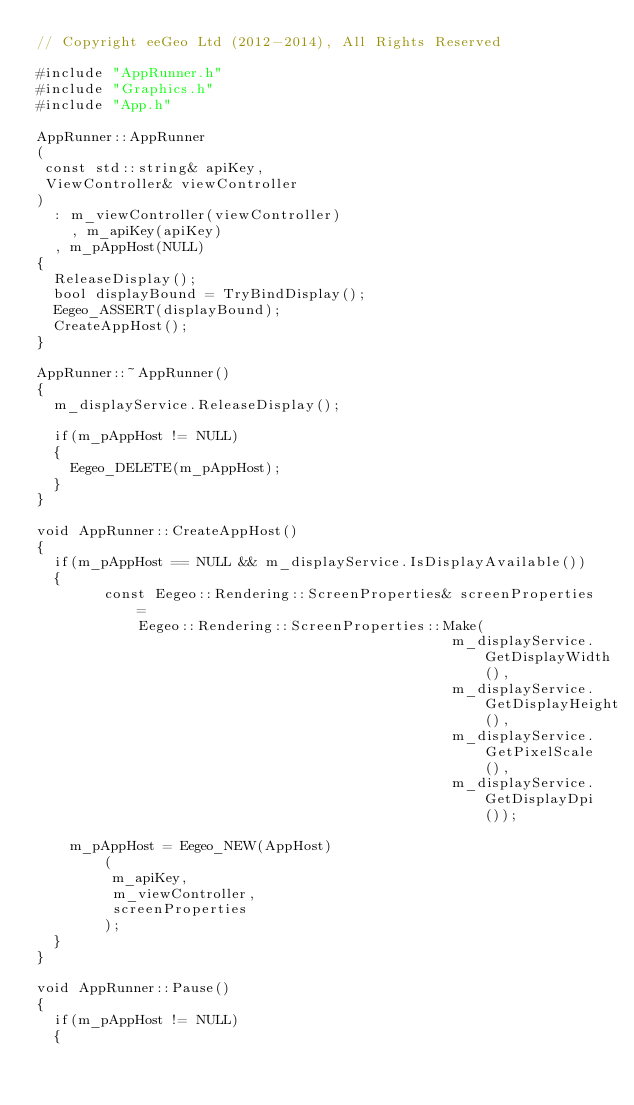<code> <loc_0><loc_0><loc_500><loc_500><_ObjectiveC_>// Copyright eeGeo Ltd (2012-2014), All Rights Reserved

#include "AppRunner.h"
#include "Graphics.h"
#include "App.h"

AppRunner::AppRunner
(
 const std::string& apiKey,
 ViewController& viewController
)
	: m_viewController(viewController)
    , m_apiKey(apiKey)
	, m_pAppHost(NULL)
{
	ReleaseDisplay();
	bool displayBound = TryBindDisplay();
	Eegeo_ASSERT(displayBound);
	CreateAppHost();
}

AppRunner::~AppRunner()
{
	m_displayService.ReleaseDisplay();

	if(m_pAppHost != NULL)
	{
		Eegeo_DELETE(m_pAppHost);
	}
}

void AppRunner::CreateAppHost()
{
	if(m_pAppHost == NULL && m_displayService.IsDisplayAvailable())
	{
        const Eegeo::Rendering::ScreenProperties& screenProperties =
            Eegeo::Rendering::ScreenProperties::Make(
                                                 m_displayService.GetDisplayWidth(),
                                                 m_displayService.GetDisplayHeight(),
                                                 m_displayService.GetPixelScale(),
                                                 m_displayService.GetDisplayDpi());
        
		m_pAppHost = Eegeo_NEW(AppHost)
        (
         m_apiKey,
         m_viewController,
         screenProperties
        );
	}
}

void AppRunner::Pause()
{
	if(m_pAppHost != NULL)
	{</code> 